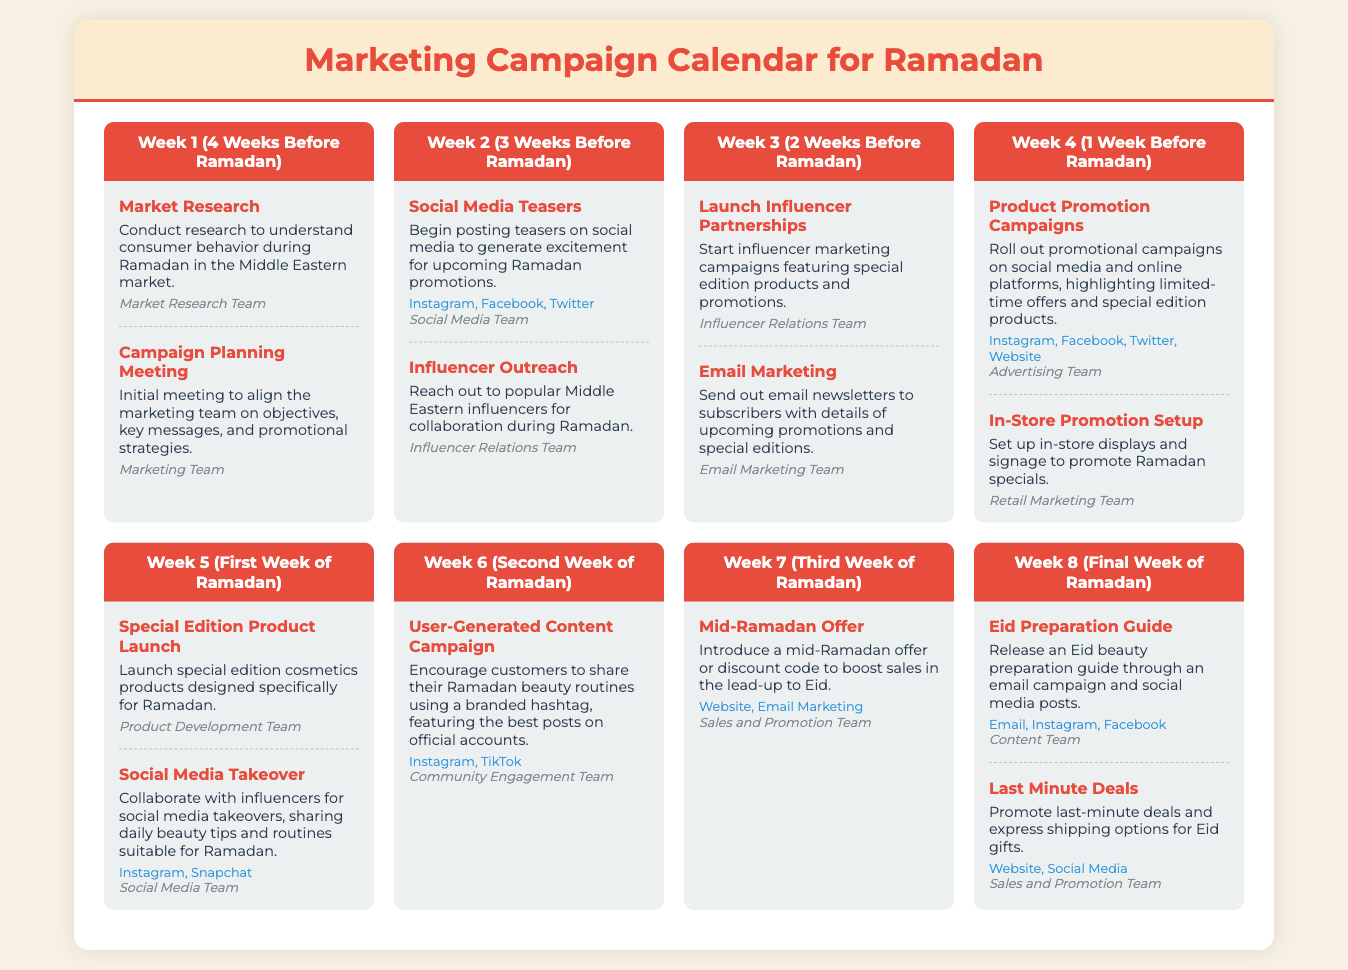What activity is planned for Week 1? The document lists Market Research and Campaign Planning Meeting as activities for Week 1.
Answer: Market Research, Campaign Planning Meeting Which week focuses on social media teasers? Social Media Teasers is scheduled in Week 2, which is 3 weeks before Ramadan.
Answer: Week 2 What is the primary goal of the User-Generated Content Campaign? This campaign encourages customers to share their Ramadan beauty routines.
Answer: Share beauty routines How many activities are scheduled in Week 4? There are two activities planned for Week 4: Product Promotion Campaigns and In-Store Promotion Setup.
Answer: 2 What is launched in Week 5? The Special Edition Product Launch is scheduled for Week 5.
Answer: Special Edition Product Launch Which platforms are utilized for the mid-Ramadan offer? The mid-Ramadan offer is promoted through the website and email marketing.
Answer: Website, Email Marketing What team handles influencer outreach? The Influencer Relations Team is responsible for influencer outreach.
Answer: Influencer Relations Team Which week includes a last-minute deals promotion? Last Minute Deals are promoted in the Final Week of Ramadan.
Answer: Final Week of Ramadan 